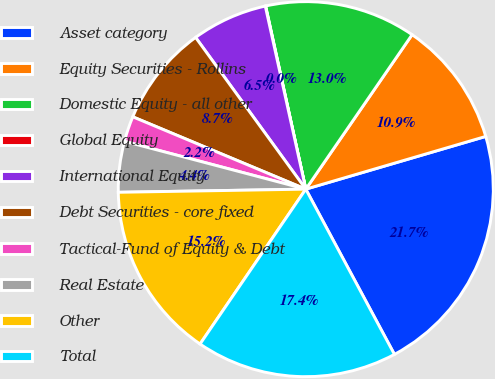Convert chart. <chart><loc_0><loc_0><loc_500><loc_500><pie_chart><fcel>Asset category<fcel>Equity Securities - Rollins<fcel>Domestic Equity - all other<fcel>Global Equity<fcel>International Equity<fcel>Debt Securities - core fixed<fcel>Tactical-Fund of Equity & Debt<fcel>Real Estate<fcel>Other<fcel>Total<nl><fcel>21.7%<fcel>10.87%<fcel>13.03%<fcel>0.03%<fcel>6.53%<fcel>8.7%<fcel>2.2%<fcel>4.37%<fcel>15.2%<fcel>17.37%<nl></chart> 